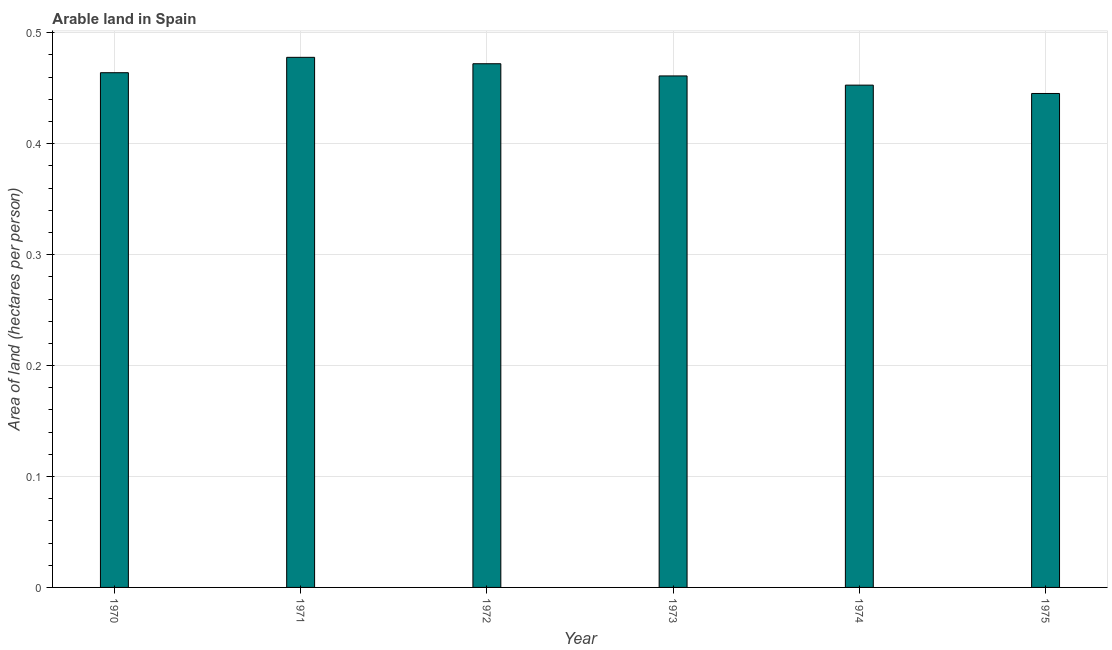Does the graph contain any zero values?
Your response must be concise. No. What is the title of the graph?
Make the answer very short. Arable land in Spain. What is the label or title of the Y-axis?
Keep it short and to the point. Area of land (hectares per person). What is the area of arable land in 1971?
Offer a very short reply. 0.48. Across all years, what is the maximum area of arable land?
Ensure brevity in your answer.  0.48. Across all years, what is the minimum area of arable land?
Offer a very short reply. 0.45. In which year was the area of arable land maximum?
Give a very brief answer. 1971. In which year was the area of arable land minimum?
Your answer should be compact. 1975. What is the sum of the area of arable land?
Make the answer very short. 2.77. What is the difference between the area of arable land in 1970 and 1971?
Your answer should be compact. -0.01. What is the average area of arable land per year?
Offer a very short reply. 0.46. What is the median area of arable land?
Offer a terse response. 0.46. Do a majority of the years between 1972 and 1970 (inclusive) have area of arable land greater than 0.02 hectares per person?
Offer a very short reply. Yes. What is the difference between the highest and the second highest area of arable land?
Give a very brief answer. 0.01. Is the sum of the area of arable land in 1972 and 1975 greater than the maximum area of arable land across all years?
Your response must be concise. Yes. What is the difference between the highest and the lowest area of arable land?
Offer a very short reply. 0.03. In how many years, is the area of arable land greater than the average area of arable land taken over all years?
Offer a terse response. 3. Are all the bars in the graph horizontal?
Offer a very short reply. No. How many years are there in the graph?
Offer a very short reply. 6. What is the difference between two consecutive major ticks on the Y-axis?
Offer a very short reply. 0.1. What is the Area of land (hectares per person) of 1970?
Your answer should be compact. 0.46. What is the Area of land (hectares per person) in 1971?
Keep it short and to the point. 0.48. What is the Area of land (hectares per person) of 1972?
Provide a succinct answer. 0.47. What is the Area of land (hectares per person) of 1973?
Provide a short and direct response. 0.46. What is the Area of land (hectares per person) in 1974?
Keep it short and to the point. 0.45. What is the Area of land (hectares per person) of 1975?
Offer a very short reply. 0.45. What is the difference between the Area of land (hectares per person) in 1970 and 1971?
Offer a very short reply. -0.01. What is the difference between the Area of land (hectares per person) in 1970 and 1972?
Your answer should be very brief. -0.01. What is the difference between the Area of land (hectares per person) in 1970 and 1973?
Your response must be concise. 0. What is the difference between the Area of land (hectares per person) in 1970 and 1974?
Provide a succinct answer. 0.01. What is the difference between the Area of land (hectares per person) in 1970 and 1975?
Your answer should be very brief. 0.02. What is the difference between the Area of land (hectares per person) in 1971 and 1972?
Offer a terse response. 0.01. What is the difference between the Area of land (hectares per person) in 1971 and 1973?
Ensure brevity in your answer.  0.02. What is the difference between the Area of land (hectares per person) in 1971 and 1974?
Ensure brevity in your answer.  0.03. What is the difference between the Area of land (hectares per person) in 1971 and 1975?
Keep it short and to the point. 0.03. What is the difference between the Area of land (hectares per person) in 1972 and 1973?
Offer a very short reply. 0.01. What is the difference between the Area of land (hectares per person) in 1972 and 1974?
Ensure brevity in your answer.  0.02. What is the difference between the Area of land (hectares per person) in 1972 and 1975?
Your answer should be very brief. 0.03. What is the difference between the Area of land (hectares per person) in 1973 and 1974?
Ensure brevity in your answer.  0.01. What is the difference between the Area of land (hectares per person) in 1973 and 1975?
Offer a terse response. 0.02. What is the difference between the Area of land (hectares per person) in 1974 and 1975?
Ensure brevity in your answer.  0.01. What is the ratio of the Area of land (hectares per person) in 1970 to that in 1973?
Offer a very short reply. 1.01. What is the ratio of the Area of land (hectares per person) in 1970 to that in 1975?
Provide a succinct answer. 1.04. What is the ratio of the Area of land (hectares per person) in 1971 to that in 1973?
Your answer should be very brief. 1.04. What is the ratio of the Area of land (hectares per person) in 1971 to that in 1974?
Your answer should be very brief. 1.05. What is the ratio of the Area of land (hectares per person) in 1971 to that in 1975?
Provide a short and direct response. 1.07. What is the ratio of the Area of land (hectares per person) in 1972 to that in 1973?
Offer a very short reply. 1.02. What is the ratio of the Area of land (hectares per person) in 1972 to that in 1974?
Your answer should be very brief. 1.04. What is the ratio of the Area of land (hectares per person) in 1972 to that in 1975?
Offer a terse response. 1.06. What is the ratio of the Area of land (hectares per person) in 1973 to that in 1975?
Make the answer very short. 1.04. What is the ratio of the Area of land (hectares per person) in 1974 to that in 1975?
Keep it short and to the point. 1.02. 